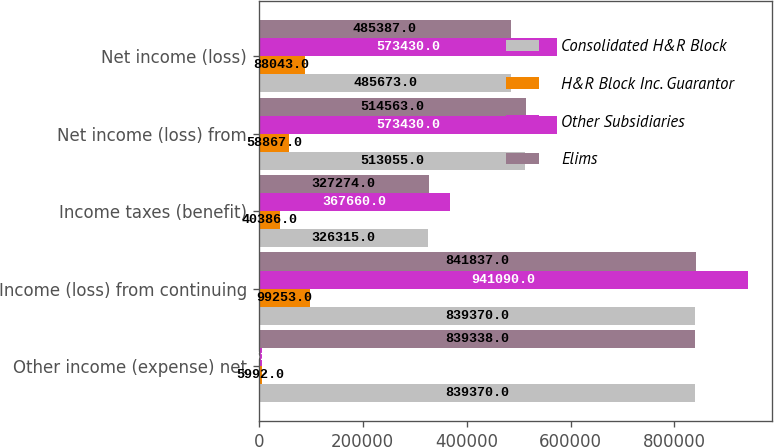<chart> <loc_0><loc_0><loc_500><loc_500><stacked_bar_chart><ecel><fcel>Other income (expense) net<fcel>Income (loss) from continuing<fcel>Income taxes (benefit)<fcel>Net income (loss) from<fcel>Net income (loss)<nl><fcel>Consolidated H&R Block<fcel>839370<fcel>839370<fcel>326315<fcel>513055<fcel>485673<nl><fcel>H&R Block Inc. Guarantor<fcel>5992<fcel>99253<fcel>40386<fcel>58867<fcel>88043<nl><fcel>Other Subsidiaries<fcel>6461<fcel>941090<fcel>367660<fcel>573430<fcel>573430<nl><fcel>Elims<fcel>839338<fcel>841837<fcel>327274<fcel>514563<fcel>485387<nl></chart> 